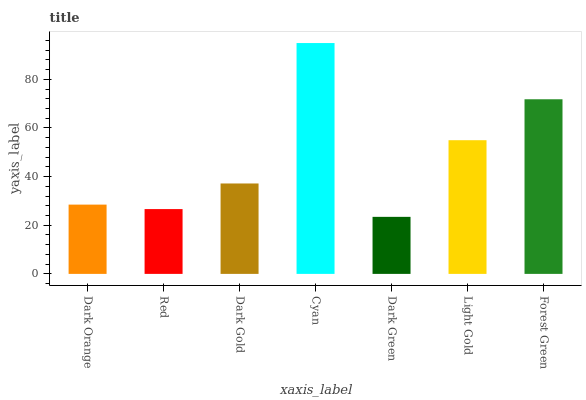Is Dark Green the minimum?
Answer yes or no. Yes. Is Cyan the maximum?
Answer yes or no. Yes. Is Red the minimum?
Answer yes or no. No. Is Red the maximum?
Answer yes or no. No. Is Dark Orange greater than Red?
Answer yes or no. Yes. Is Red less than Dark Orange?
Answer yes or no. Yes. Is Red greater than Dark Orange?
Answer yes or no. No. Is Dark Orange less than Red?
Answer yes or no. No. Is Dark Gold the high median?
Answer yes or no. Yes. Is Dark Gold the low median?
Answer yes or no. Yes. Is Dark Green the high median?
Answer yes or no. No. Is Forest Green the low median?
Answer yes or no. No. 